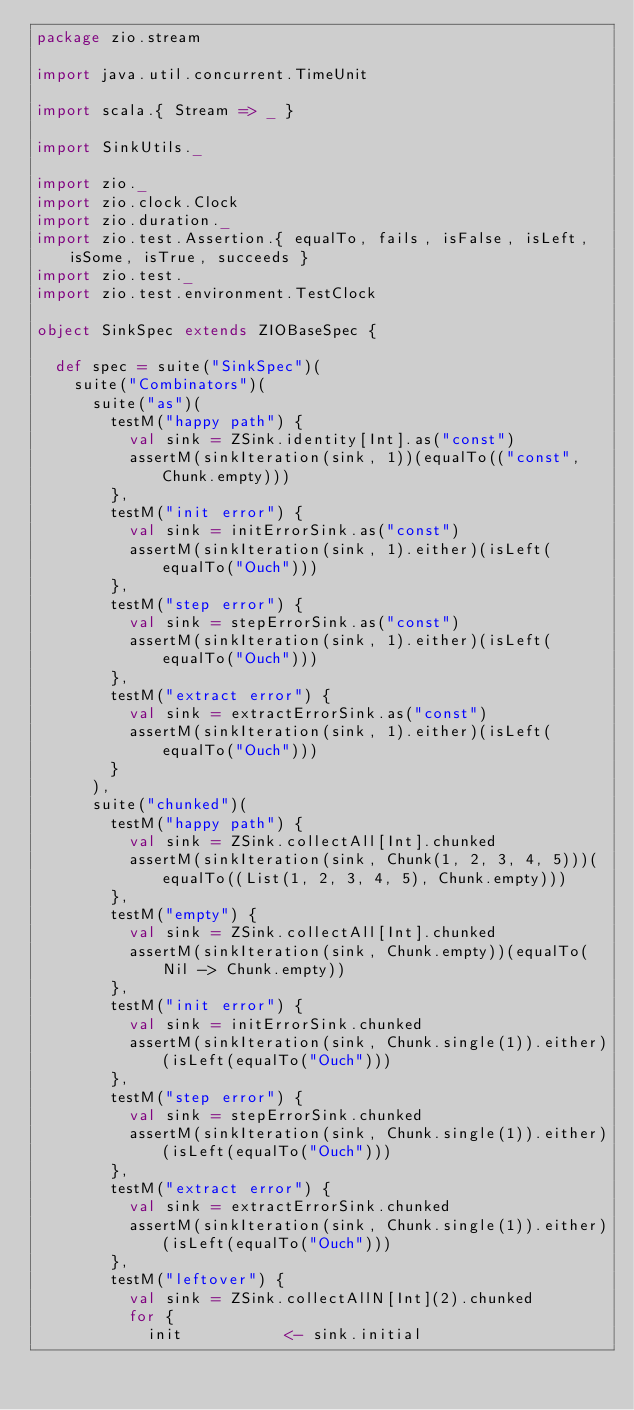<code> <loc_0><loc_0><loc_500><loc_500><_Scala_>package zio.stream

import java.util.concurrent.TimeUnit

import scala.{ Stream => _ }

import SinkUtils._

import zio._
import zio.clock.Clock
import zio.duration._
import zio.test.Assertion.{ equalTo, fails, isFalse, isLeft, isSome, isTrue, succeeds }
import zio.test._
import zio.test.environment.TestClock

object SinkSpec extends ZIOBaseSpec {

  def spec = suite("SinkSpec")(
    suite("Combinators")(
      suite("as")(
        testM("happy path") {
          val sink = ZSink.identity[Int].as("const")
          assertM(sinkIteration(sink, 1))(equalTo(("const", Chunk.empty)))
        },
        testM("init error") {
          val sink = initErrorSink.as("const")
          assertM(sinkIteration(sink, 1).either)(isLeft(equalTo("Ouch")))
        },
        testM("step error") {
          val sink = stepErrorSink.as("const")
          assertM(sinkIteration(sink, 1).either)(isLeft(equalTo("Ouch")))
        },
        testM("extract error") {
          val sink = extractErrorSink.as("const")
          assertM(sinkIteration(sink, 1).either)(isLeft(equalTo("Ouch")))
        }
      ),
      suite("chunked")(
        testM("happy path") {
          val sink = ZSink.collectAll[Int].chunked
          assertM(sinkIteration(sink, Chunk(1, 2, 3, 4, 5)))(equalTo((List(1, 2, 3, 4, 5), Chunk.empty)))
        },
        testM("empty") {
          val sink = ZSink.collectAll[Int].chunked
          assertM(sinkIteration(sink, Chunk.empty))(equalTo(Nil -> Chunk.empty))
        },
        testM("init error") {
          val sink = initErrorSink.chunked
          assertM(sinkIteration(sink, Chunk.single(1)).either)(isLeft(equalTo("Ouch")))
        },
        testM("step error") {
          val sink = stepErrorSink.chunked
          assertM(sinkIteration(sink, Chunk.single(1)).either)(isLeft(equalTo("Ouch")))
        },
        testM("extract error") {
          val sink = extractErrorSink.chunked
          assertM(sinkIteration(sink, Chunk.single(1)).either)(isLeft(equalTo("Ouch")))
        },
        testM("leftover") {
          val sink = ZSink.collectAllN[Int](2).chunked
          for {
            init           <- sink.initial</code> 